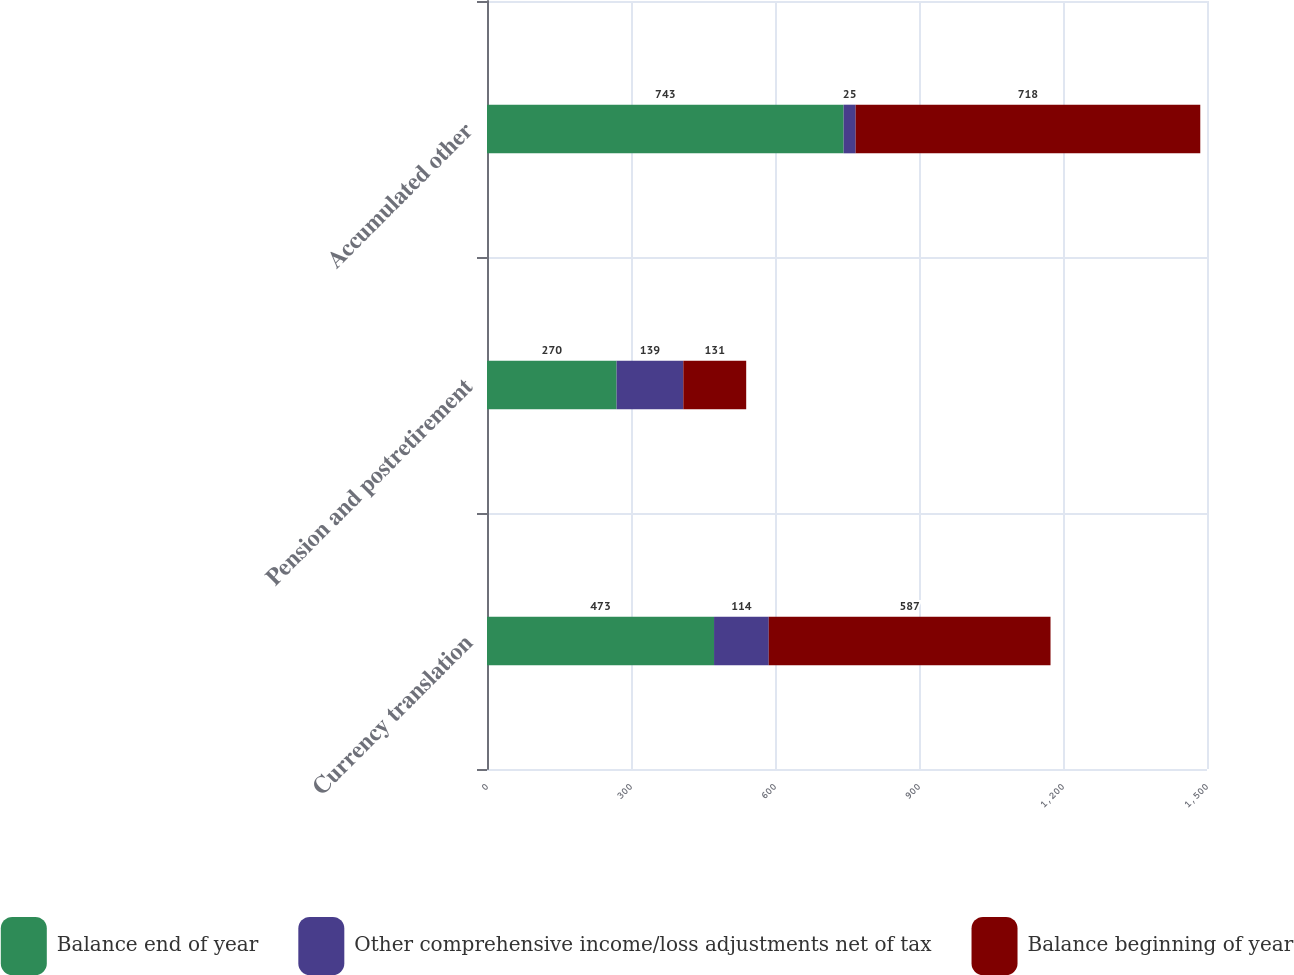<chart> <loc_0><loc_0><loc_500><loc_500><stacked_bar_chart><ecel><fcel>Currency translation<fcel>Pension and postretirement<fcel>Accumulated other<nl><fcel>Balance end of year<fcel>473<fcel>270<fcel>743<nl><fcel>Other comprehensive income/loss adjustments net of tax<fcel>114<fcel>139<fcel>25<nl><fcel>Balance beginning of year<fcel>587<fcel>131<fcel>718<nl></chart> 